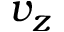Convert formula to latex. <formula><loc_0><loc_0><loc_500><loc_500>v _ { z }</formula> 